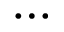<formula> <loc_0><loc_0><loc_500><loc_500>\cdots</formula> 